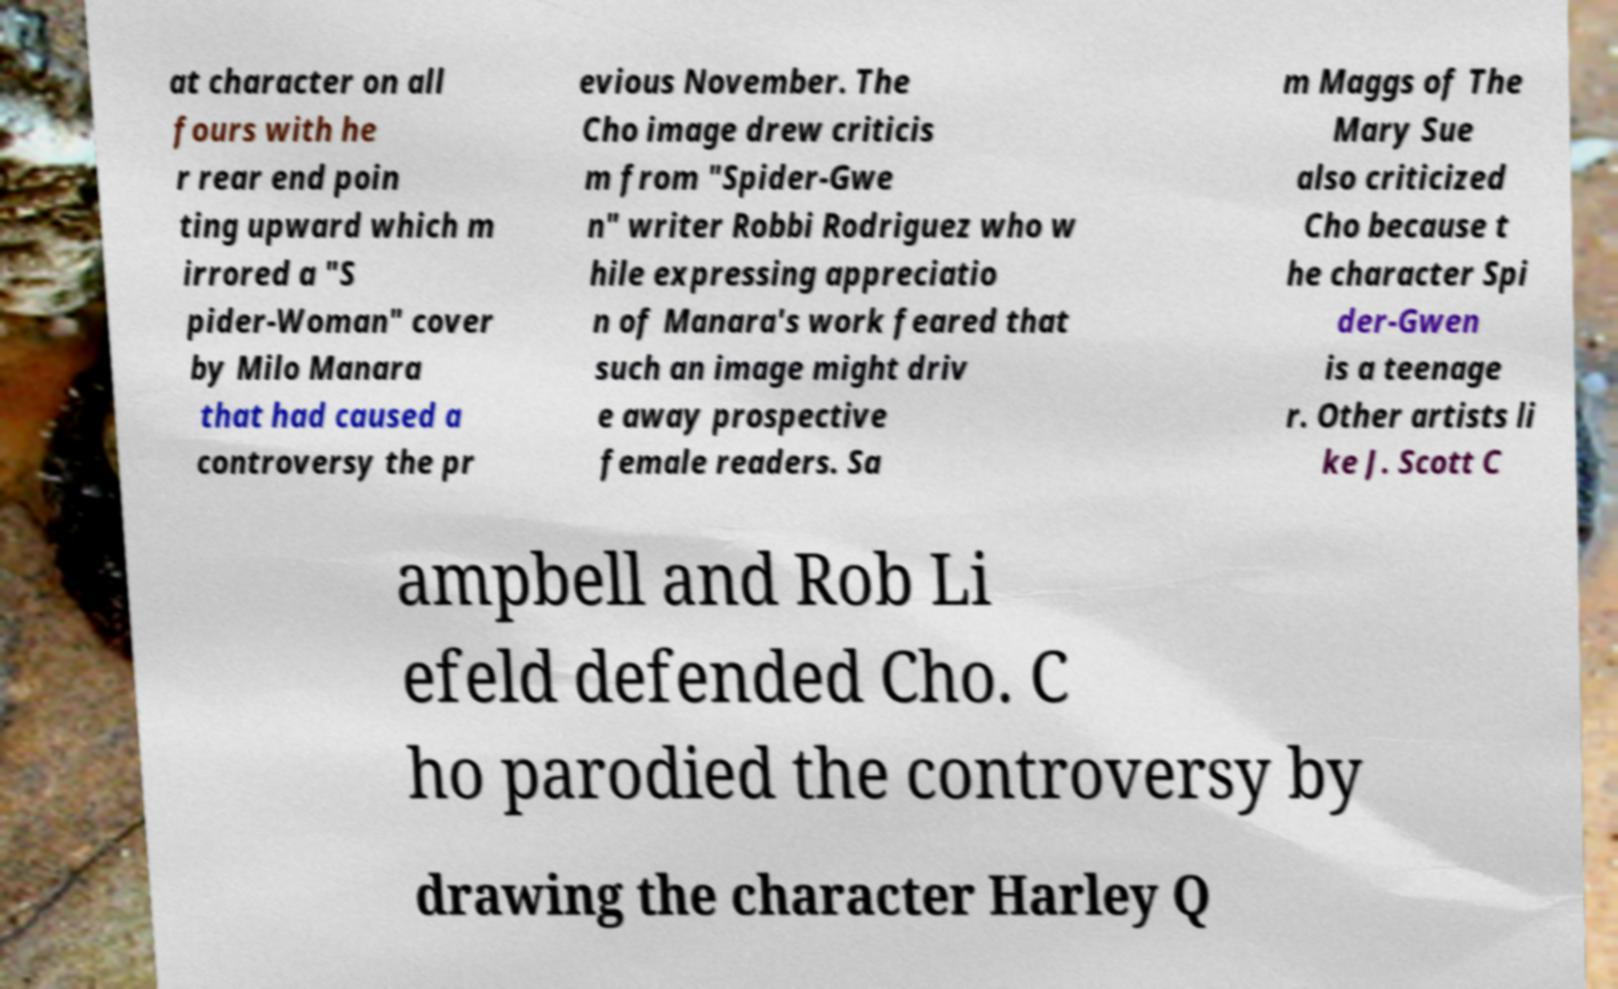There's text embedded in this image that I need extracted. Can you transcribe it verbatim? at character on all fours with he r rear end poin ting upward which m irrored a "S pider-Woman" cover by Milo Manara that had caused a controversy the pr evious November. The Cho image drew criticis m from "Spider-Gwe n" writer Robbi Rodriguez who w hile expressing appreciatio n of Manara's work feared that such an image might driv e away prospective female readers. Sa m Maggs of The Mary Sue also criticized Cho because t he character Spi der-Gwen is a teenage r. Other artists li ke J. Scott C ampbell and Rob Li efeld defended Cho. C ho parodied the controversy by drawing the character Harley Q 